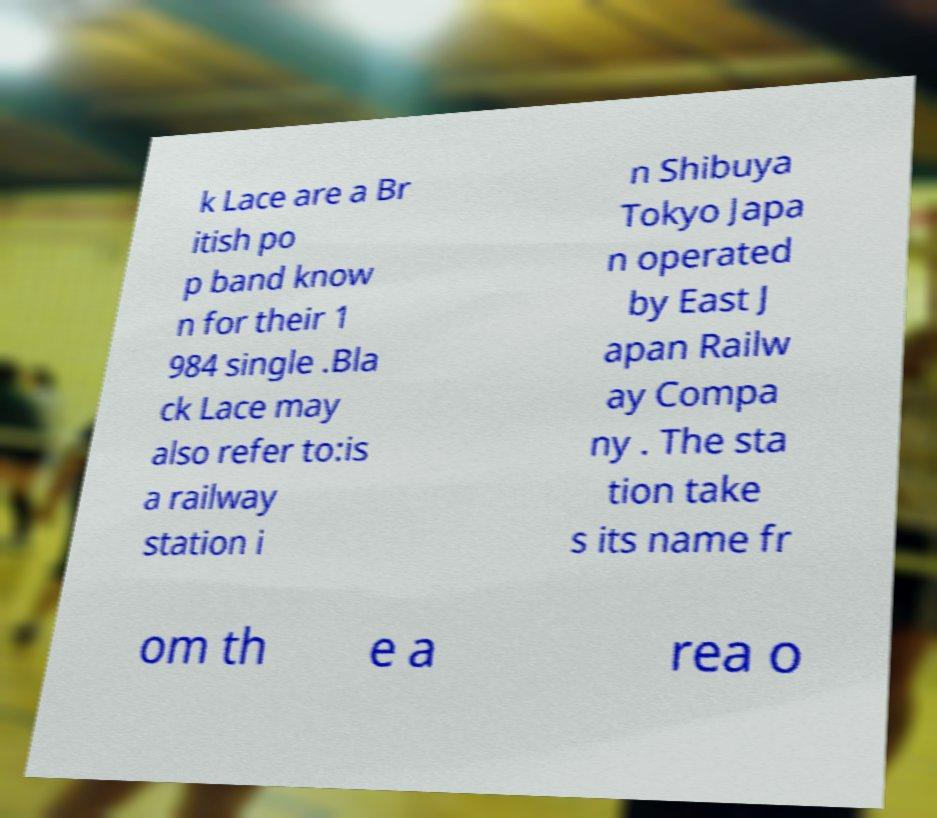Could you assist in decoding the text presented in this image and type it out clearly? k Lace are a Br itish po p band know n for their 1 984 single .Bla ck Lace may also refer to:is a railway station i n Shibuya Tokyo Japa n operated by East J apan Railw ay Compa ny . The sta tion take s its name fr om th e a rea o 